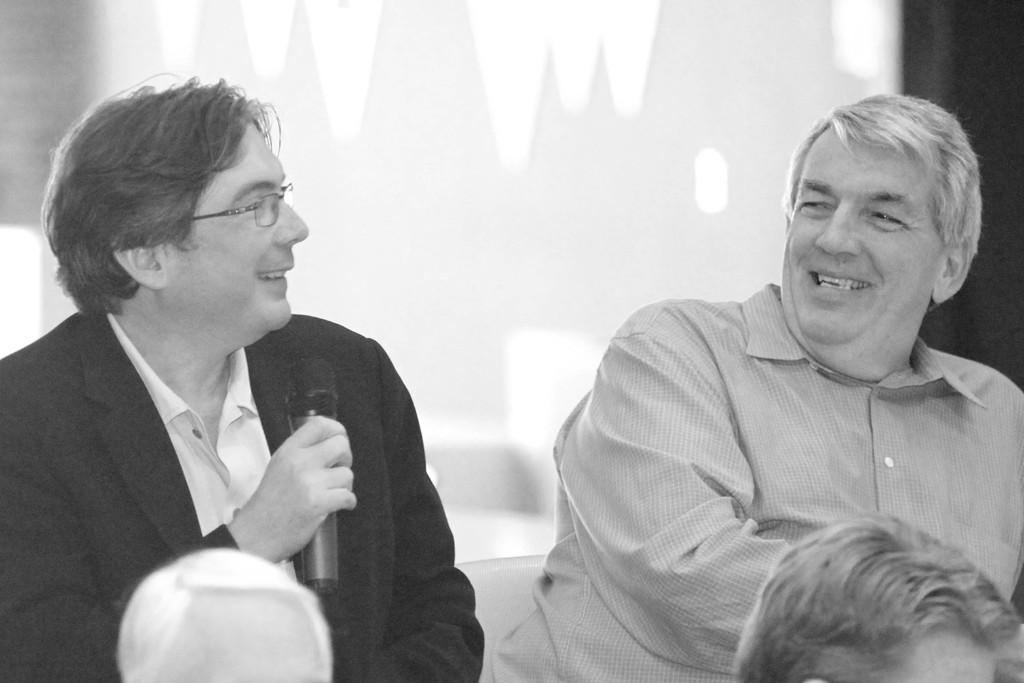What is the primary activity of the men in the image? The men in the image are sitting. Can you describe what one of the men is holding? One of the men is holding a mic in his hands. How many cars are parked behind the men in the image? There is no information about cars in the image; it only shows men sitting and one holding a mic. 